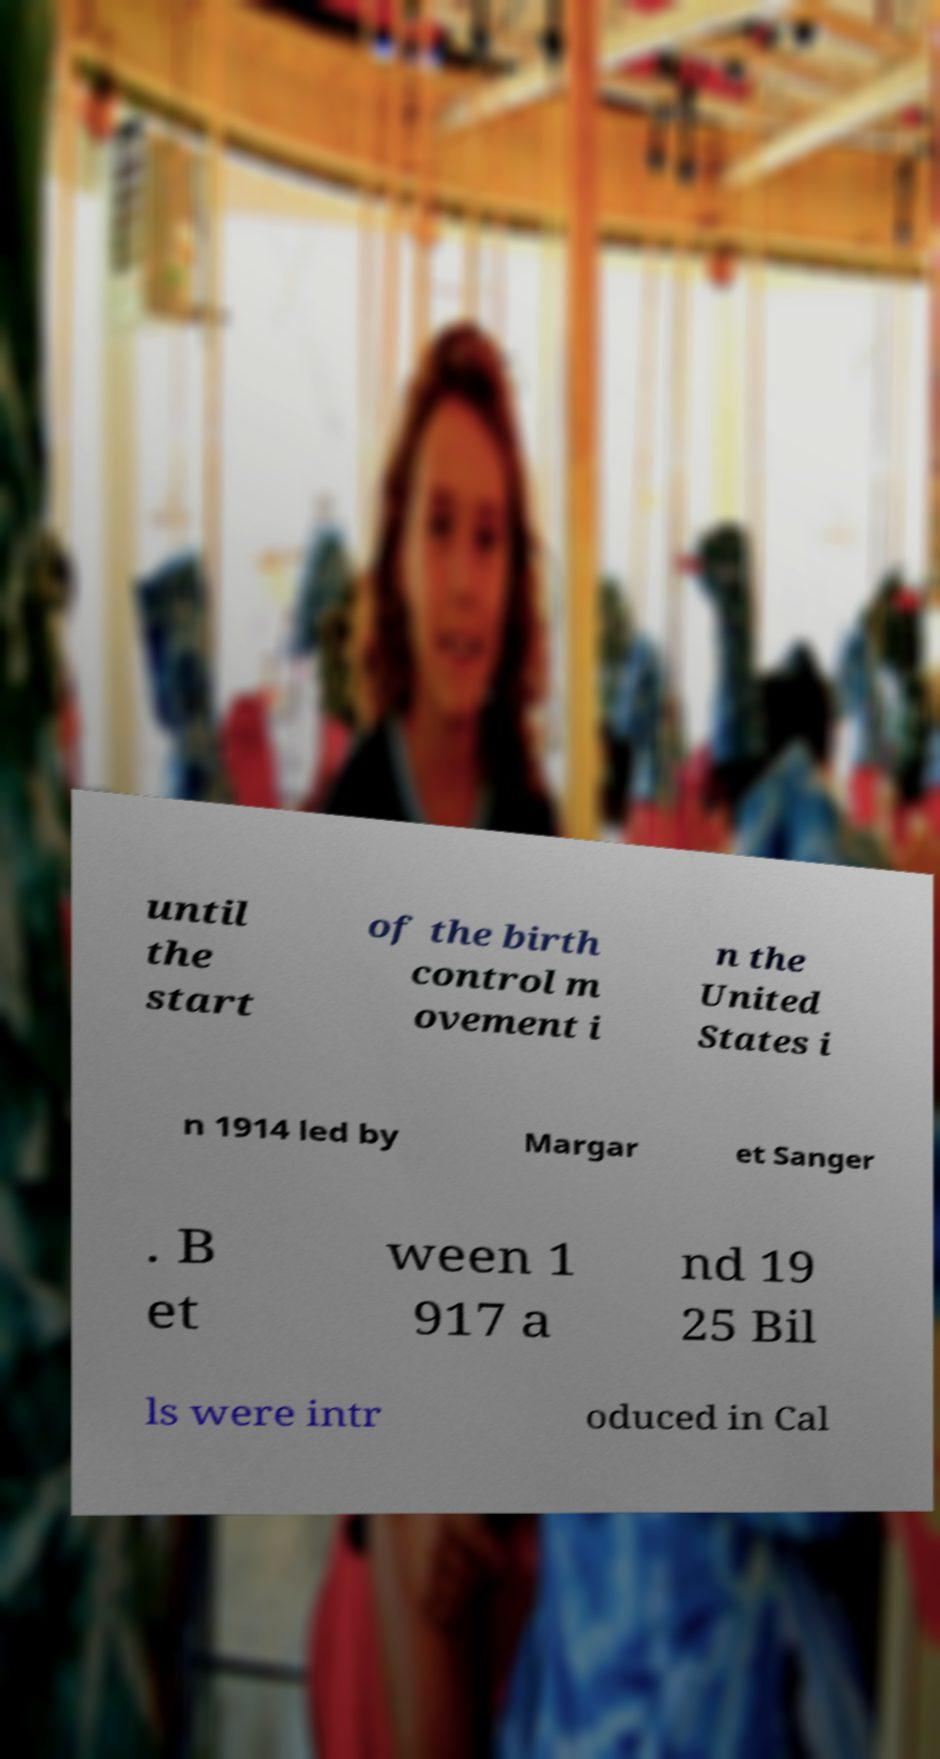I need the written content from this picture converted into text. Can you do that? until the start of the birth control m ovement i n the United States i n 1914 led by Margar et Sanger . B et ween 1 917 a nd 19 25 Bil ls were intr oduced in Cal 